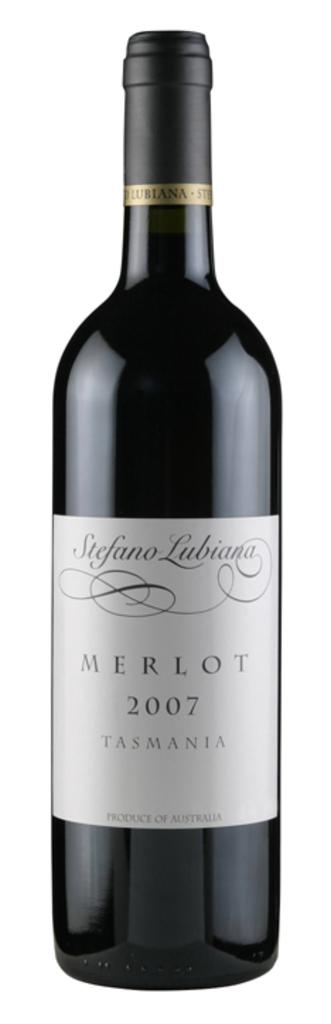<image>
Write a terse but informative summary of the picture. A bottle of 2007 Merlot by Stefano Lubiana is standing against a white background 